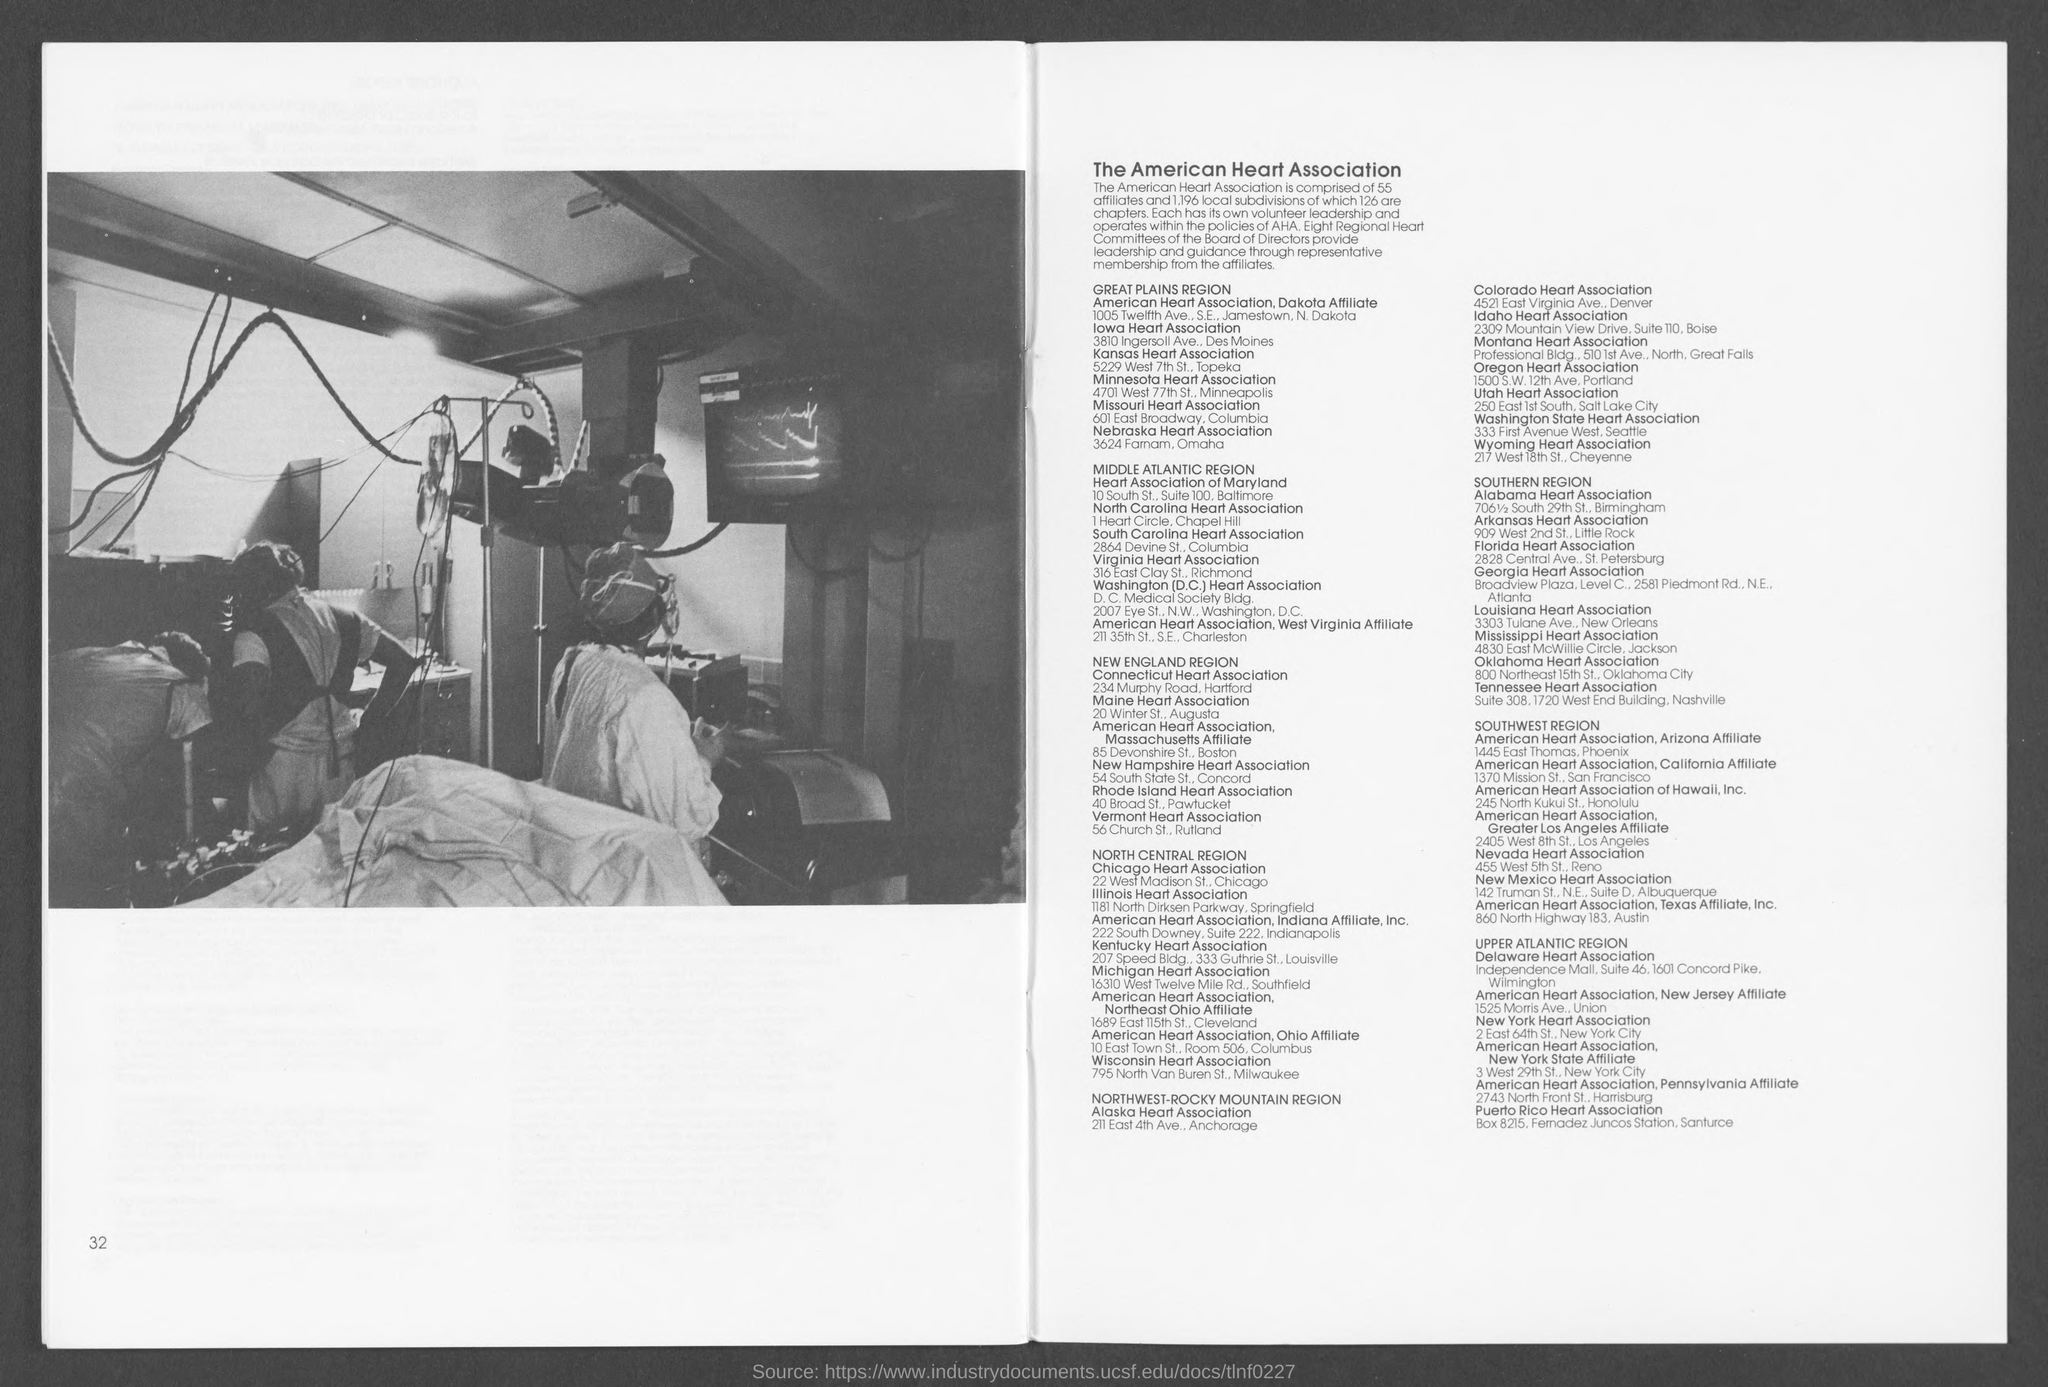Indicate a few pertinent items in this graphic. Eight Regional Heart Committees, led by the Board of Directors, provide leadership and guidance to the organization. The Nebraska Heart Association can be found at 3624 Farnam Street in Omaha. The Mississippi Heart Association is located at 4830 East McWillie Circle in Jackson, Mississippi. The American Heart Association has 55 affiliates. The number of chapters mentioned is 126. 